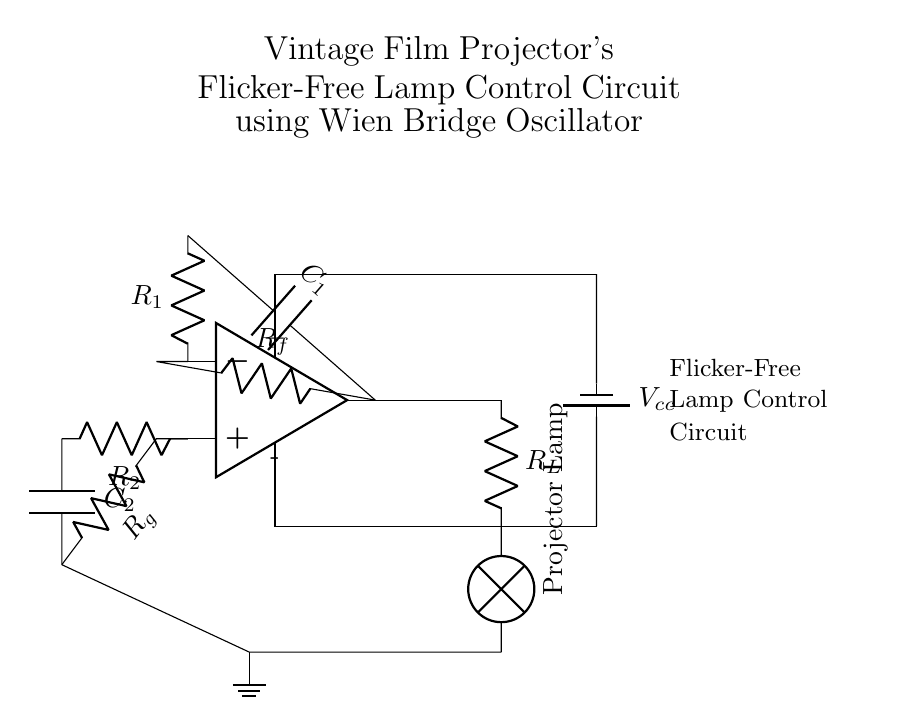What is the main function of the Wien Bridge oscillator in this circuit? The main function of the Wien Bridge oscillator is to generate a stable sine wave signal, which is accomplished through the feedback network of resistors and capacitors connected around the operational amplifier.
Answer: generate sine wave What components are included in the feedback network of the oscillator? The feedback network of the oscillator includes the resistors R1 and R2, and the capacitors C1 and C2. These components are essential for establishing the oscillation condition and frequency.
Answer: R1, R2, C1, C2 What type of lamp is controlled in this circuit? The lamp controlled in this circuit is a projector lamp. Its function is to provide a flicker-free light source essential for vintage film projection.
Answer: Projector Lamp How is the output from the Wien Bridge oscillator connected to the lamp? The output from the Wien Bridge oscillator is connected directly to a load resistor R_L, which is then connected in series with the projector lamp, allowing the oscillating signal to drive the lamp.
Answer: Through load resistor R_L What is the role of resistor R_f in this circuit? Resistor R_f acts as a feedback resistor in the Wien Bridge oscillator that helps to stabilize the gain of the circuit, balancing the positive and negative feedback needed for oscillation.
Answer: Stabilize gain What is the supply voltage for this circuit? The supply voltage for this circuit is denoted as V_cc, which is connected to the operational amplifier to power the whole circuit.
Answer: V_cc 